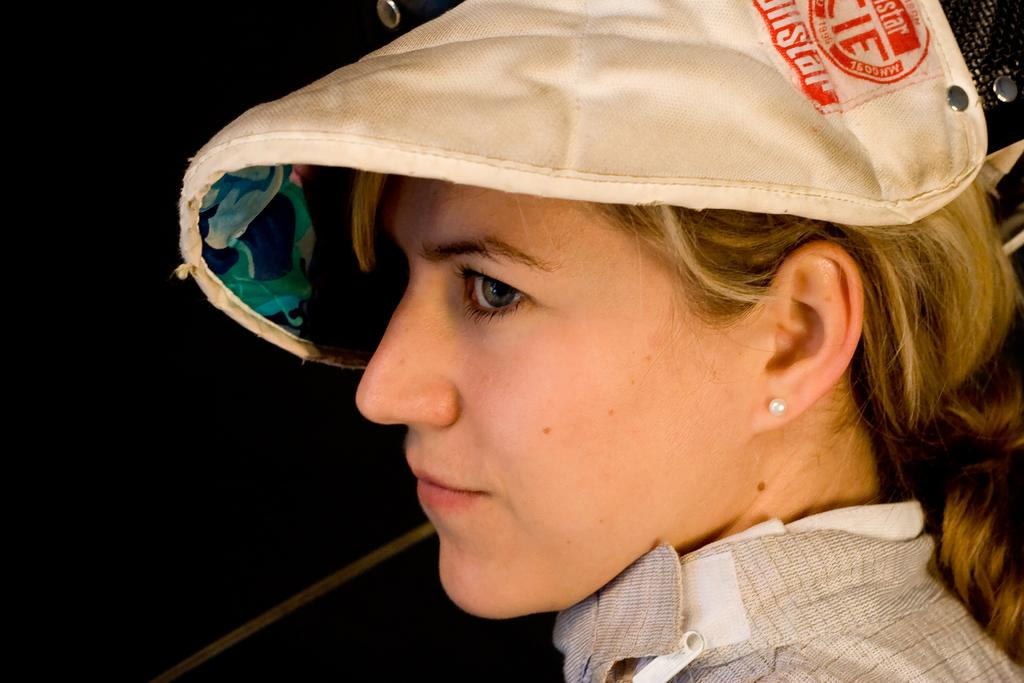Who is the main subject in the image? There is a woman in the image. What is the woman wearing on her head? The woman is wearing a white cap. Can you describe the background of the image? The background of the image is dark. What is the butter doing in the image? There is no butter present in the image. In which direction is the woman facing in the image? The provided facts do not specify the direction the woman is facing. 